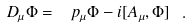<formula> <loc_0><loc_0><loc_500><loc_500>D _ { \mu } \Phi = \ p _ { \mu } \Phi - i [ A _ { \mu } , \Phi ] \ .</formula> 